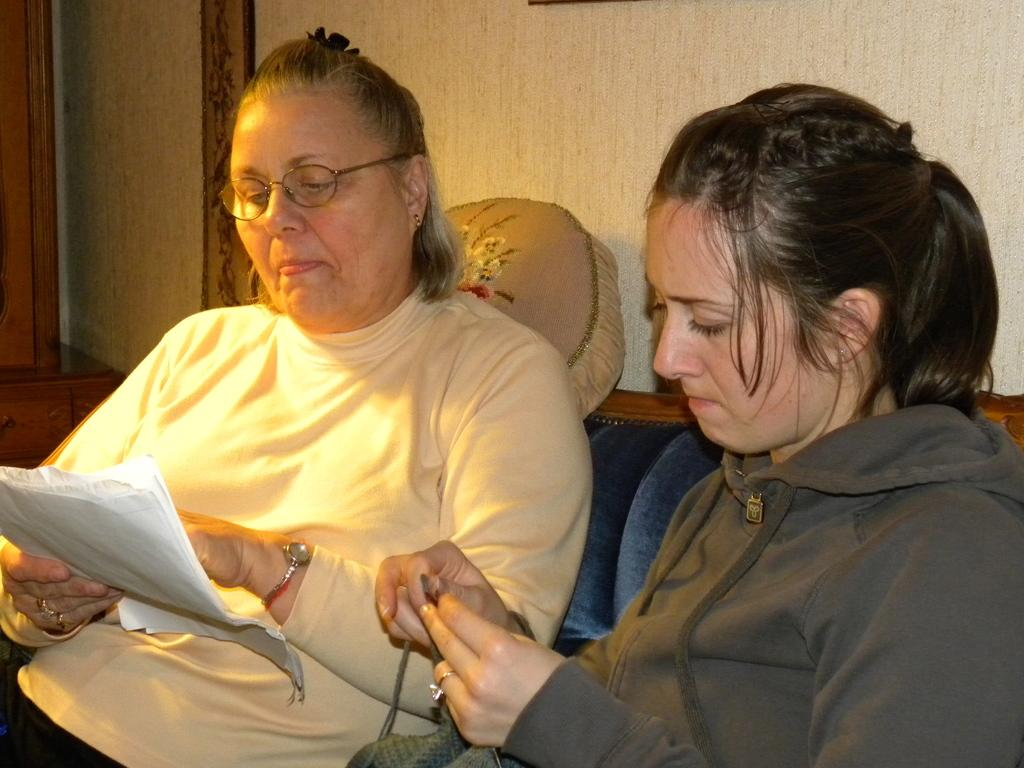What is the person in the image doing? The person is sitting on a bench. What activity is the person engaged in while sitting on the bench? The person is reading a book. What type of education can be seen on the back of the person in the image? There is no information about the person's education in the image, and the back of the person is not visible. 